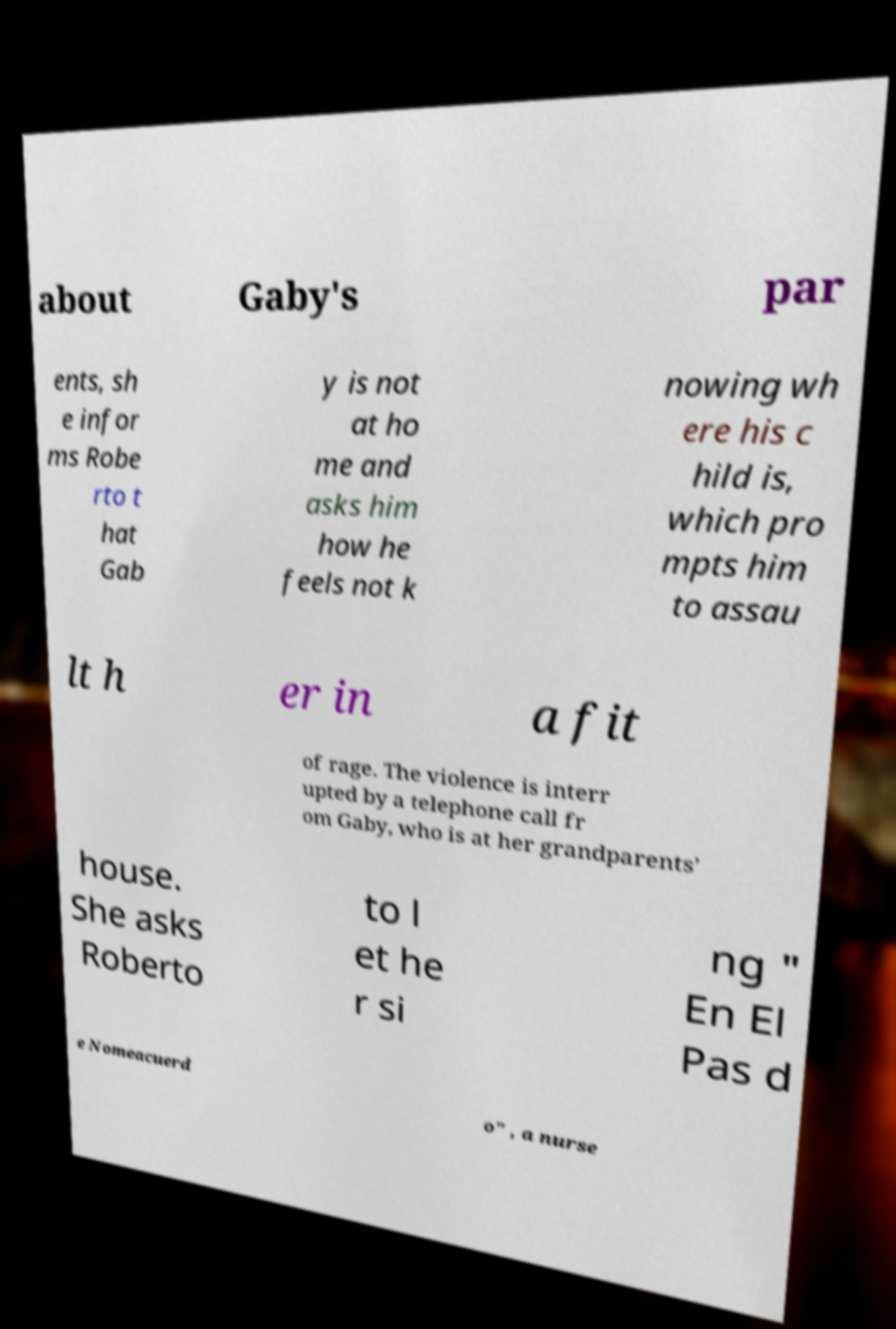What messages or text are displayed in this image? I need them in a readable, typed format. about Gaby's par ents, sh e infor ms Robe rto t hat Gab y is not at ho me and asks him how he feels not k nowing wh ere his c hild is, which pro mpts him to assau lt h er in a fit of rage. The violence is interr upted by a telephone call fr om Gaby, who is at her grandparents’ house. She asks Roberto to l et he r si ng " En El Pas d e Nomeacuerd o" , a nurse 